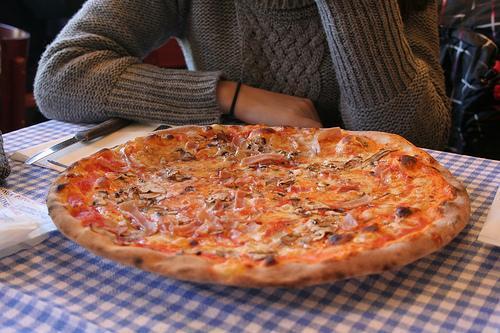How many pizza pies are there?
Give a very brief answer. 1. 